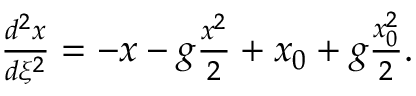<formula> <loc_0><loc_0><loc_500><loc_500>\begin{array} { r } { \frac { d ^ { 2 } x } { d \xi ^ { 2 } } = - x - g \frac { x ^ { 2 } } { 2 } + x _ { 0 } + g \frac { x _ { 0 } ^ { 2 } } { 2 } . } \end{array}</formula> 